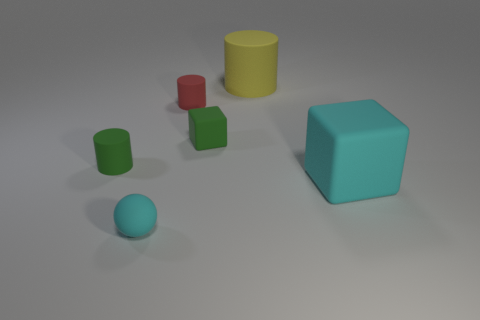Subtract 1 cylinders. How many cylinders are left? 2 Add 2 big cyan objects. How many objects exist? 8 Subtract all cubes. How many objects are left? 4 Subtract 0 brown cubes. How many objects are left? 6 Subtract all rubber cubes. Subtract all tiny brown shiny spheres. How many objects are left? 4 Add 5 red things. How many red things are left? 6 Add 4 blue metal objects. How many blue metal objects exist? 4 